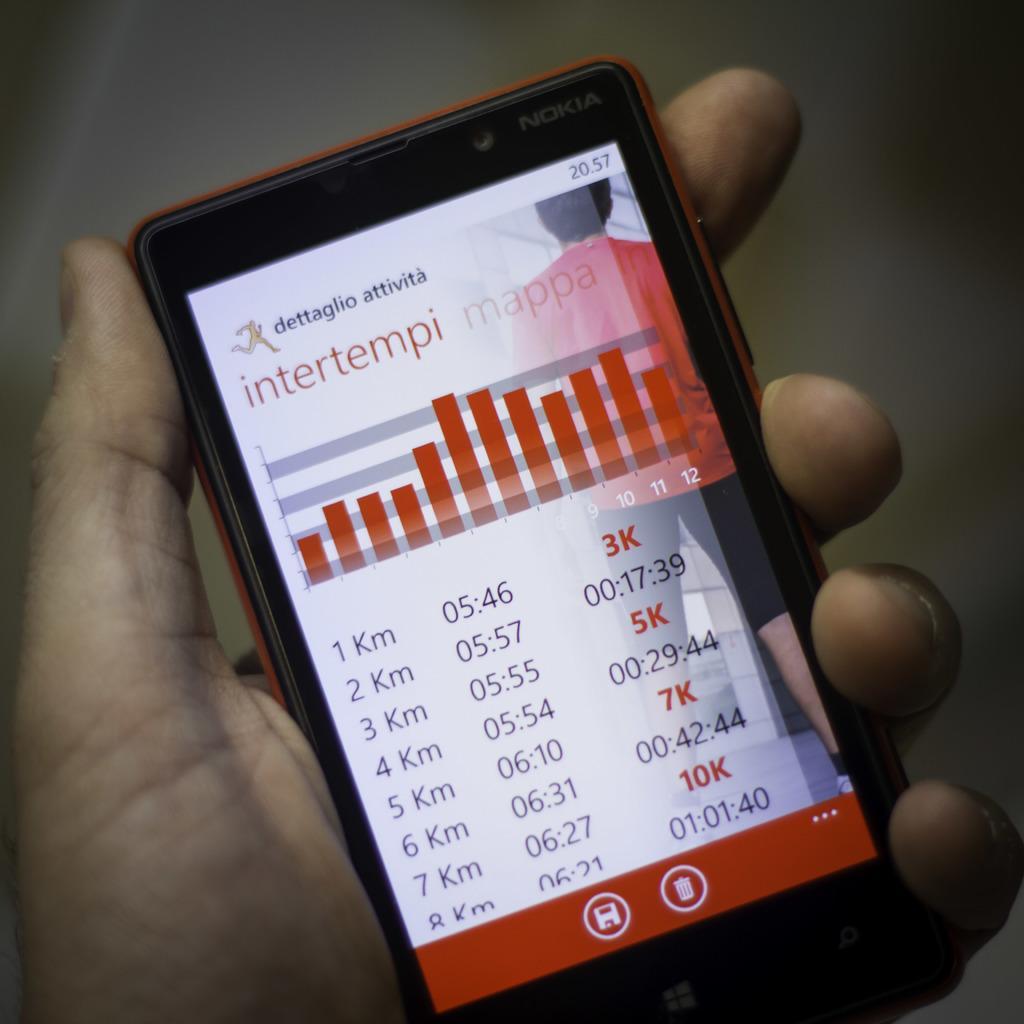Could you give a brief overview of what you see in this image? In this picture we can see some data on the mobile display. Someone is holding the mobile in their hand. 